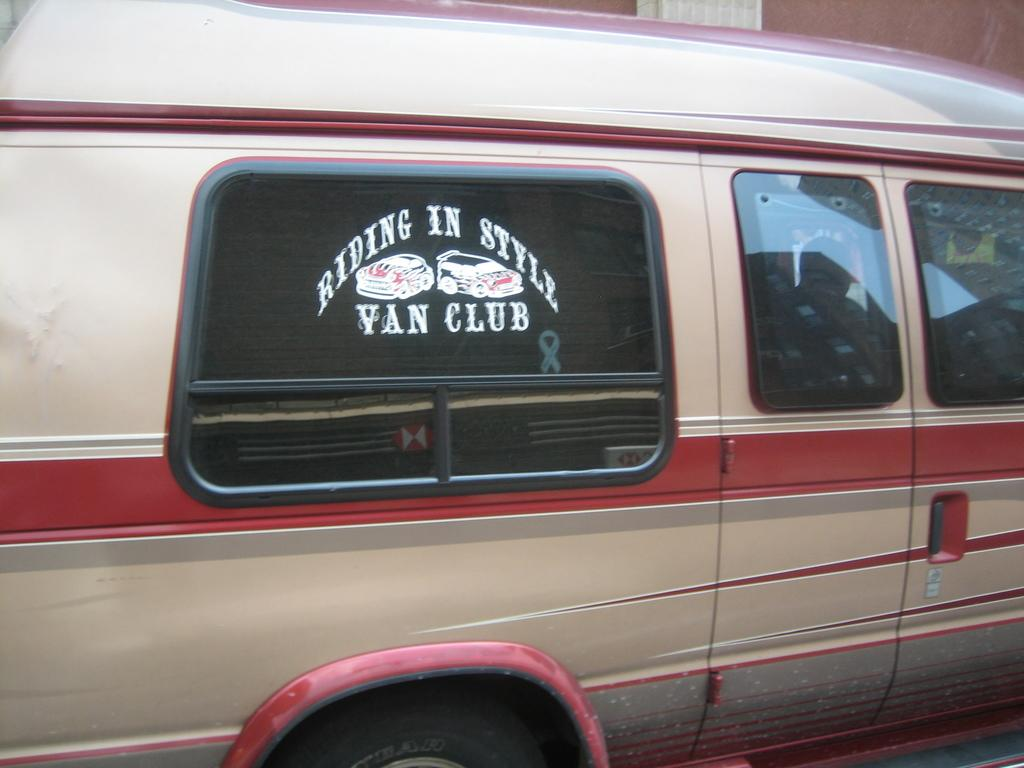<image>
Share a concise interpretation of the image provided. A conversion van has a sticker saying they belong in the Riding In Style van club. 